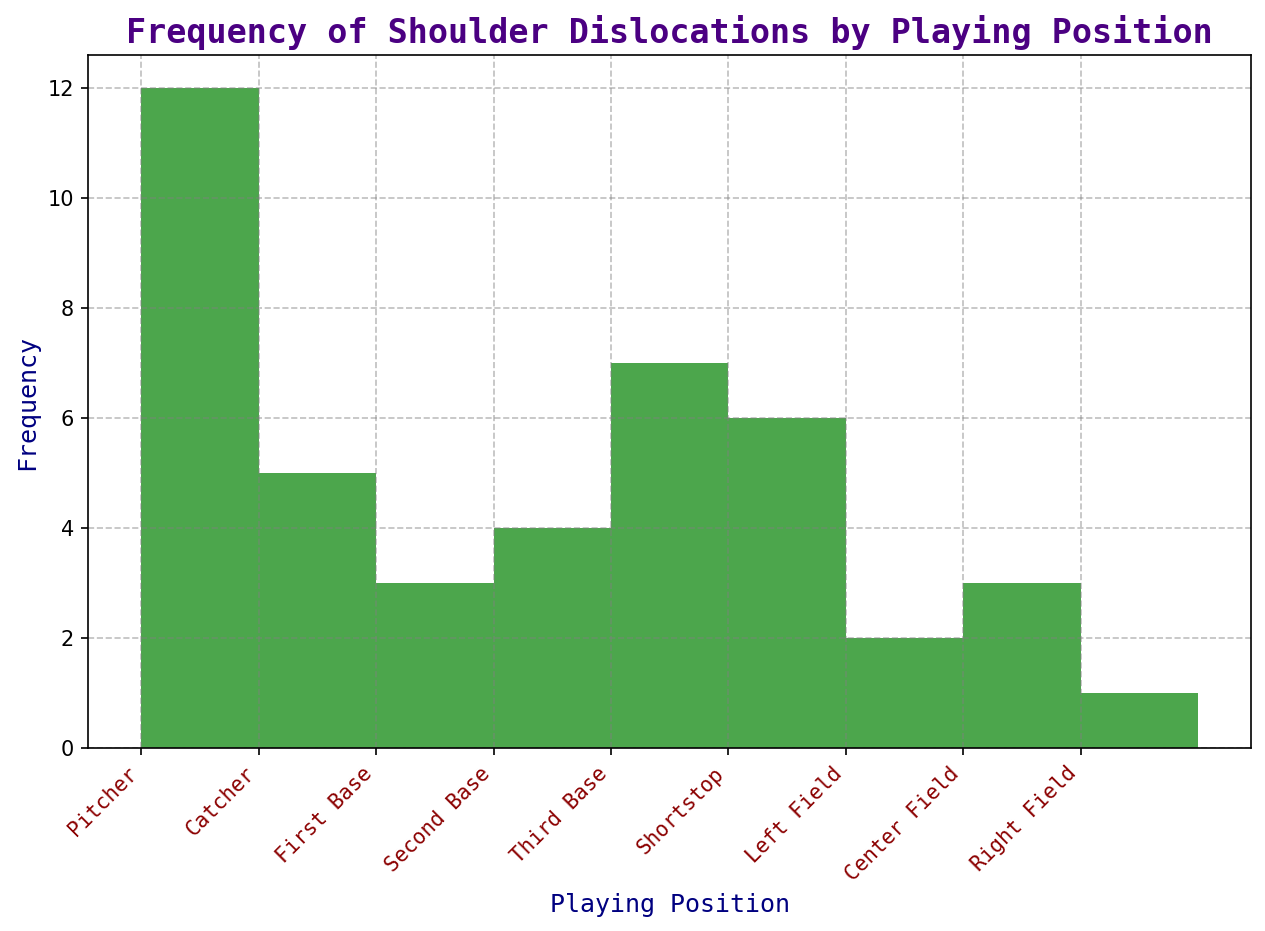Which playing position has the highest frequency of shoulder dislocations? The figure shows that the "Pitcher" position has the highest bar at the frequency mark of 12.
Answer: Pitcher Which playing position has the lowest frequency of shoulder dislocations? The figure shows the lowest bar belongs to the "Right Field" position with a frequency of 1.
Answer: Right Field How many more shoulder dislocations do Pitchers have compared to First Basemen? The frequency for Pitchers is 12 and for First Basemen is 3. The difference is 12 - 3 = 9.
Answer: 9 Which outfield position has the highest frequency of shoulder dislocations? The outfield positions are Left Field (2), Center Field (3), and Right Field (1). Among them, Center Field has the highest frequency at 3.
Answer: Center Field What is the average frequency of shoulder dislocations for infield positions (excluding pitcher and catcher)? Infield positions are First Base (3), Second Base (4), Third Base (7), and Shortstop (6). The total is 3 + 4 + 7 + 6 = 20. The average is 20 / 4 = 5.
Answer: 5 How does the frequency of shoulder dislocations for Shortstop compare to Catcher? Shortstop has a frequency of 6, and Catcher has a frequency of 5. Therefore, Shortstop has 1 more than Catcher.
Answer: 1 more Which playing positions have a frequency of shoulder dislocations greater than or equal to 6? By examining the heights of the bars, the positions are Pitcher (12), Third Base (7), and Shortstop (6).
Answer: Pitcher, Third Base, Shortstop What is the combined frequency of shoulder dislocations for outfield positions (Left Field, Center Field, Right Field)? The frequencies are Left Field (2), Center Field (3), Right Field (1). The combined total is 2 + 3 + 1 = 6.
Answer: 6 Are there more shoulder dislocations in infield positions or outfield positions? Summing infield positions (excluding Pitcher and Catcher): First Base (3), Second Base (4), Third Base (7), Shortstop (6); total = 20. Summing outfield: Left Field (2), Center Field (3), Right Field (1); total = 6. Thus, infield has more.
Answer: Infield What is the range of frequencies for shoulder dislocations among all playing positions? The highest frequency is 12 (Pitcher) and the lowest is 1 (Right Field). The range is 12 - 1 = 11.
Answer: 11 